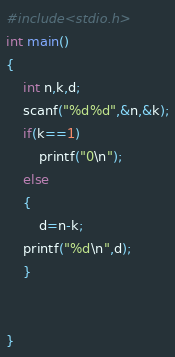Convert code to text. <code><loc_0><loc_0><loc_500><loc_500><_C_>#include<stdio.h>
int main()
{
    int n,k,d;
    scanf("%d%d",&n,&k);
    if(k==1)
        printf("0\n");
    else
    {
        d=n-k;
    printf("%d\n",d);
    }


}
</code> 